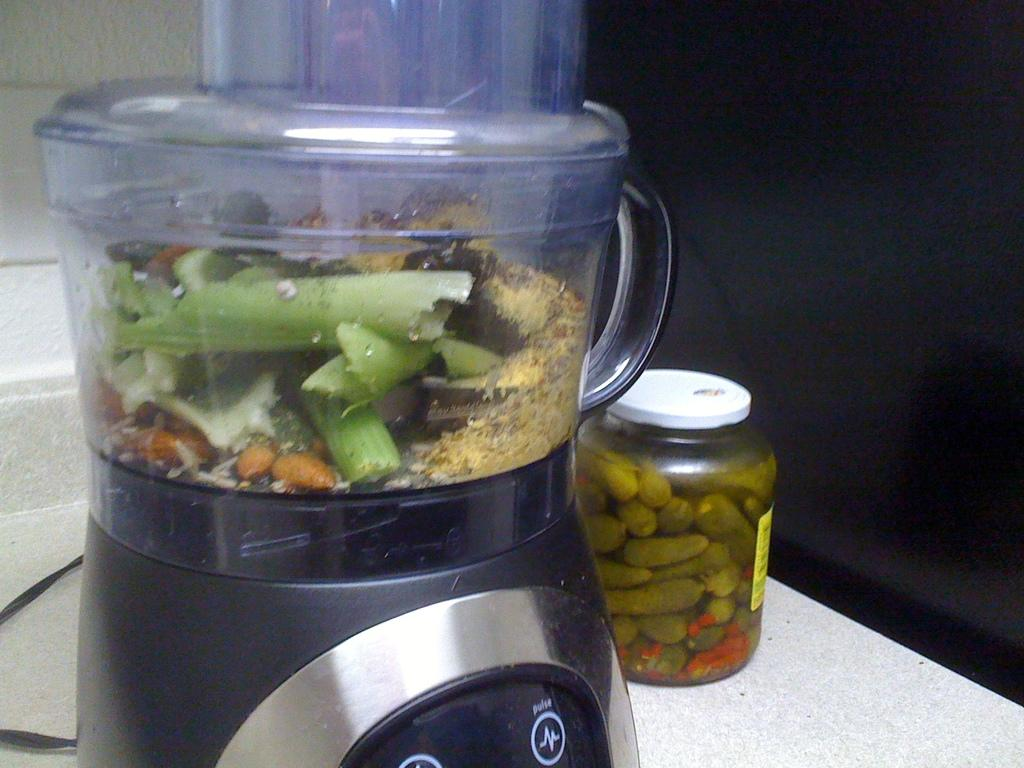What appliance can be seen in the image? There is a mixer in the image. What type of container is present in the image? There is a jar in the image. Is there any connecting wire or cable visible in the image? Yes, there is a cable in the image. What is the color of the surface on which the objects are placed? The objects are on a white surface. What type of knee injury can be seen in the image? There is no knee injury present in the image; it only features a mixer, a jar, and a cable on a white surface. Is there a bed visible in the image? No, there is no bed present in the image. 